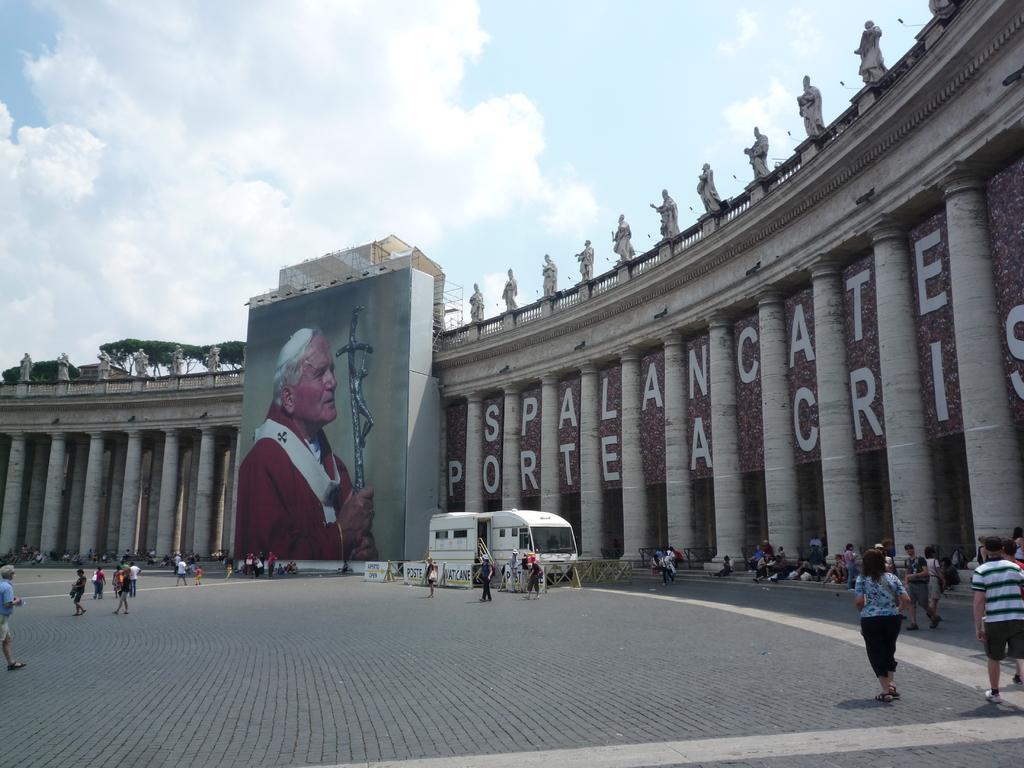Can you describe this image briefly? In this image we can see building, statues, advertisement, grills, motor vehicle on the road, persons standing on the road, persons sitting on the stairs, trees and sky with clouds. 